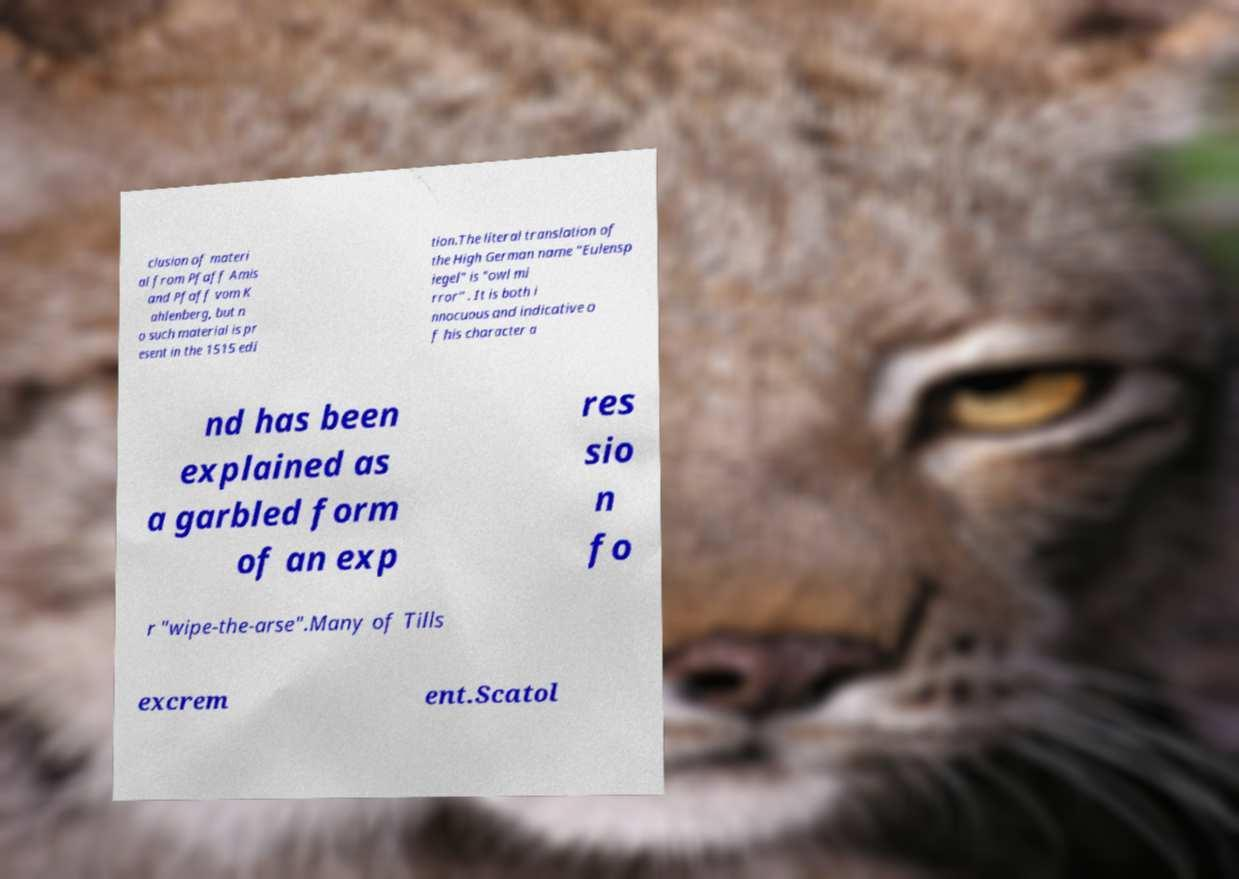I need the written content from this picture converted into text. Can you do that? clusion of materi al from Pfaff Amis and Pfaff vom K ahlenberg, but n o such material is pr esent in the 1515 edi tion.The literal translation of the High German name "Eulensp iegel" is "owl mi rror" . It is both i nnocuous and indicative o f his character a nd has been explained as a garbled form of an exp res sio n fo r "wipe-the-arse".Many of Tills excrem ent.Scatol 